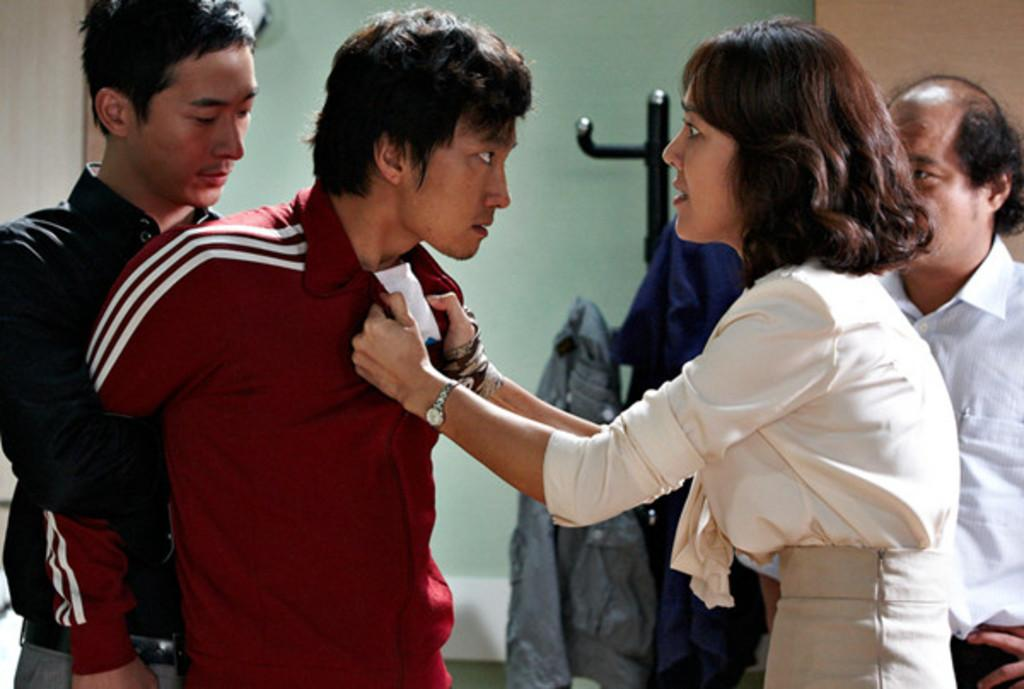What can be seen in the foreground of the image? There are people standing in the front of the image. What is located in the background of the image? There are clothes on a stand in the background of the image. What type of bun is being used to hold the toys in the image? There is no bun or toys present in the image. What statement can be made about the people in the image? The provided facts do not give any information about the people's statements or actions, so we cannot make any statements about them. 